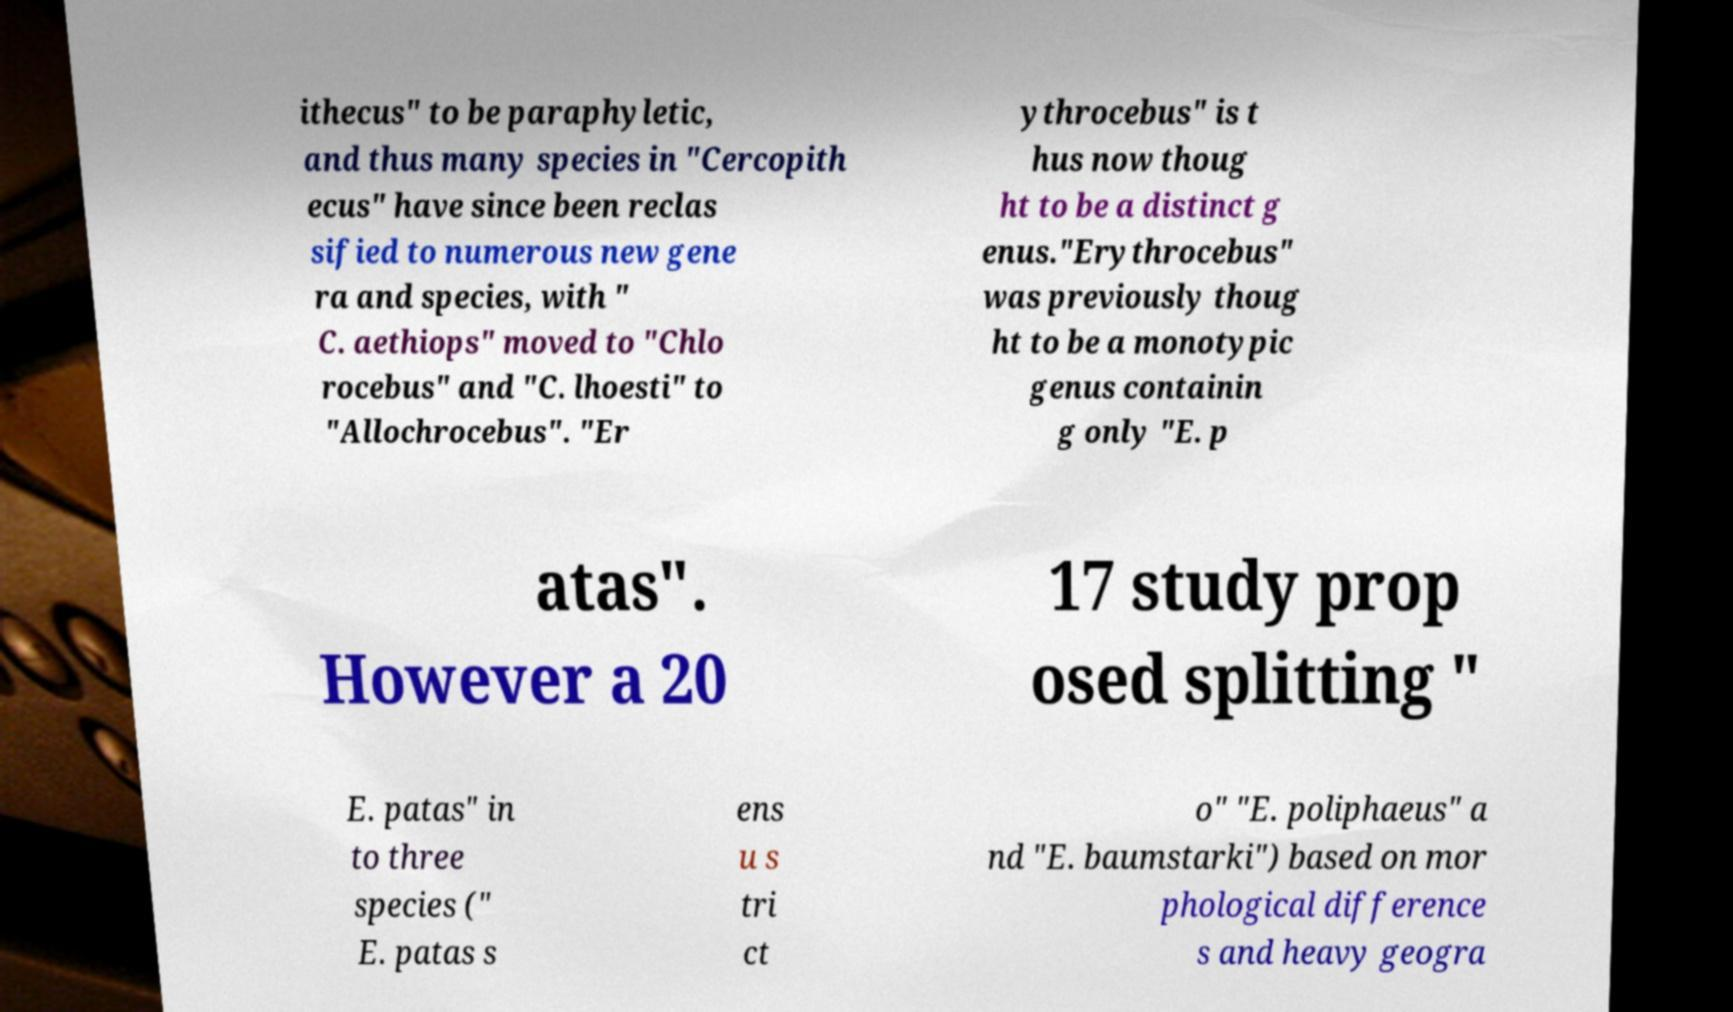Please read and relay the text visible in this image. What does it say? ithecus" to be paraphyletic, and thus many species in "Cercopith ecus" have since been reclas sified to numerous new gene ra and species, with " C. aethiops" moved to "Chlo rocebus" and "C. lhoesti" to "Allochrocebus". "Er ythrocebus" is t hus now thoug ht to be a distinct g enus."Erythrocebus" was previously thoug ht to be a monotypic genus containin g only "E. p atas". However a 20 17 study prop osed splitting " E. patas" in to three species (" E. patas s ens u s tri ct o" "E. poliphaeus" a nd "E. baumstarki") based on mor phological difference s and heavy geogra 